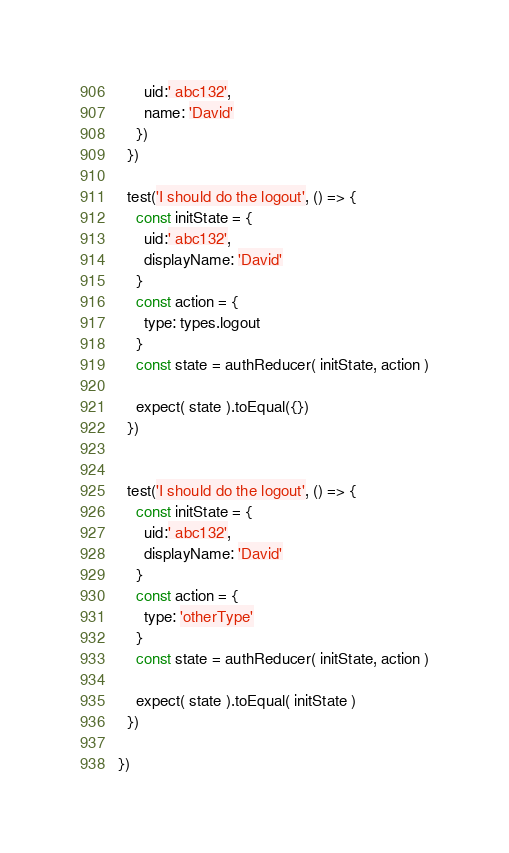<code> <loc_0><loc_0><loc_500><loc_500><_JavaScript_>      uid:' abc132',
      name: 'David'
    })
  })
  
  test('I should do the logout', () => {
    const initState = {
      uid:' abc132',
      displayName: 'David'
    }
    const action = {
      type: types.logout
    }
    const state = authReducer( initState, action )

    expect( state ).toEqual({})
  })
  
  
  test('I should do the logout', () => {
    const initState = {
      uid:' abc132',
      displayName: 'David'
    }
    const action = {
      type: 'otherType'
    }
    const state = authReducer( initState, action )

    expect( state ).toEqual( initState )
  })
  
})
</code> 